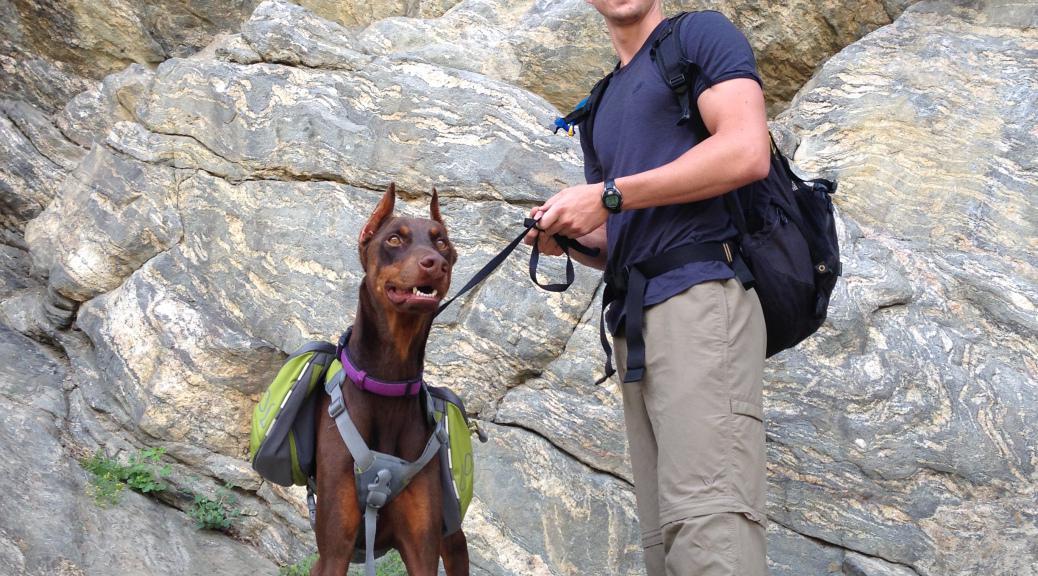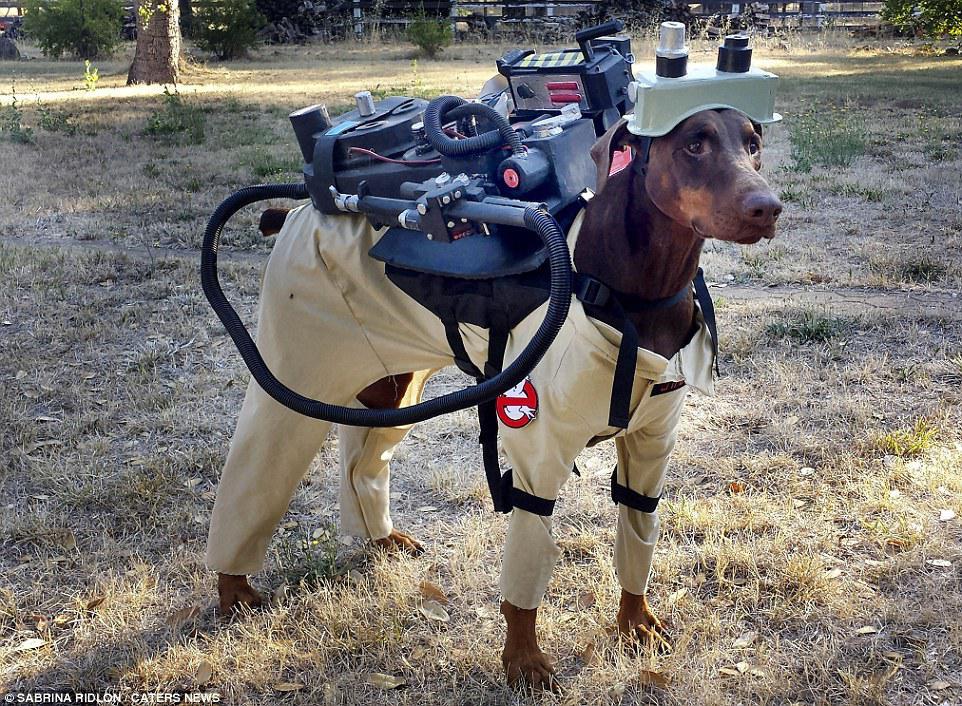The first image is the image on the left, the second image is the image on the right. Considering the images on both sides, is "A man with a backpack is standing with a dog in the image on the left." valid? Answer yes or no. Yes. 